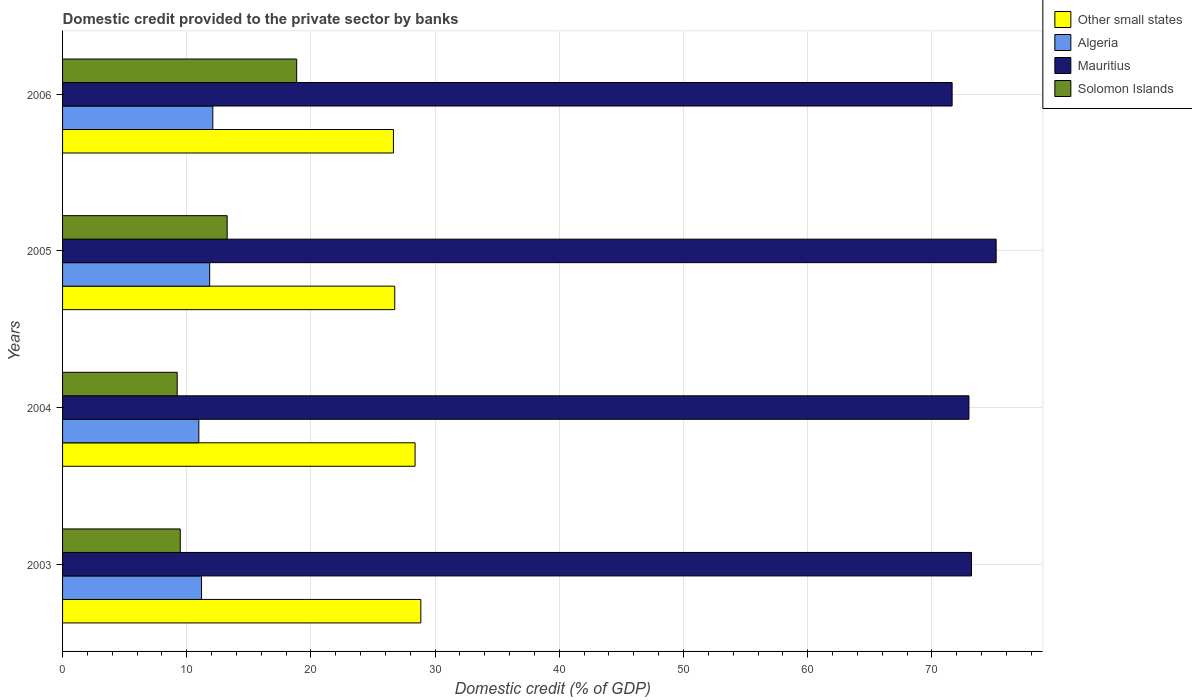How many different coloured bars are there?
Your response must be concise. 4. How many groups of bars are there?
Make the answer very short. 4. Are the number of bars on each tick of the Y-axis equal?
Make the answer very short. Yes. In how many cases, is the number of bars for a given year not equal to the number of legend labels?
Ensure brevity in your answer.  0. What is the domestic credit provided to the private sector by banks in Other small states in 2006?
Your answer should be very brief. 26.64. Across all years, what is the maximum domestic credit provided to the private sector by banks in Solomon Islands?
Your answer should be very brief. 18.85. Across all years, what is the minimum domestic credit provided to the private sector by banks in Other small states?
Provide a succinct answer. 26.64. In which year was the domestic credit provided to the private sector by banks in Other small states minimum?
Make the answer very short. 2006. What is the total domestic credit provided to the private sector by banks in Solomon Islands in the graph?
Make the answer very short. 50.81. What is the difference between the domestic credit provided to the private sector by banks in Solomon Islands in 2003 and that in 2006?
Make the answer very short. -9.37. What is the difference between the domestic credit provided to the private sector by banks in Algeria in 2004 and the domestic credit provided to the private sector by banks in Solomon Islands in 2003?
Give a very brief answer. 1.5. What is the average domestic credit provided to the private sector by banks in Mauritius per year?
Give a very brief answer. 73.25. In the year 2003, what is the difference between the domestic credit provided to the private sector by banks in Mauritius and domestic credit provided to the private sector by banks in Other small states?
Give a very brief answer. 44.34. In how many years, is the domestic credit provided to the private sector by banks in Solomon Islands greater than 72 %?
Your answer should be compact. 0. What is the ratio of the domestic credit provided to the private sector by banks in Algeria in 2003 to that in 2005?
Your answer should be very brief. 0.94. Is the difference between the domestic credit provided to the private sector by banks in Mauritius in 2003 and 2005 greater than the difference between the domestic credit provided to the private sector by banks in Other small states in 2003 and 2005?
Your answer should be compact. No. What is the difference between the highest and the second highest domestic credit provided to the private sector by banks in Mauritius?
Keep it short and to the point. 1.98. What is the difference between the highest and the lowest domestic credit provided to the private sector by banks in Mauritius?
Give a very brief answer. 3.55. In how many years, is the domestic credit provided to the private sector by banks in Algeria greater than the average domestic credit provided to the private sector by banks in Algeria taken over all years?
Offer a terse response. 2. Is it the case that in every year, the sum of the domestic credit provided to the private sector by banks in Algeria and domestic credit provided to the private sector by banks in Mauritius is greater than the sum of domestic credit provided to the private sector by banks in Other small states and domestic credit provided to the private sector by banks in Solomon Islands?
Keep it short and to the point. Yes. What does the 4th bar from the top in 2005 represents?
Your answer should be compact. Other small states. What does the 1st bar from the bottom in 2006 represents?
Offer a terse response. Other small states. How many bars are there?
Offer a terse response. 16. What is the difference between two consecutive major ticks on the X-axis?
Provide a short and direct response. 10. Are the values on the major ticks of X-axis written in scientific E-notation?
Provide a succinct answer. No. Does the graph contain any zero values?
Offer a terse response. No. Does the graph contain grids?
Give a very brief answer. Yes. How many legend labels are there?
Offer a terse response. 4. What is the title of the graph?
Ensure brevity in your answer.  Domestic credit provided to the private sector by banks. Does "United States" appear as one of the legend labels in the graph?
Your response must be concise. No. What is the label or title of the X-axis?
Provide a succinct answer. Domestic credit (% of GDP). What is the Domestic credit (% of GDP) of Other small states in 2003?
Offer a terse response. 28.85. What is the Domestic credit (% of GDP) of Algeria in 2003?
Your response must be concise. 11.19. What is the Domestic credit (% of GDP) in Mauritius in 2003?
Keep it short and to the point. 73.19. What is the Domestic credit (% of GDP) in Solomon Islands in 2003?
Your answer should be very brief. 9.48. What is the Domestic credit (% of GDP) in Other small states in 2004?
Keep it short and to the point. 28.39. What is the Domestic credit (% of GDP) of Algeria in 2004?
Your response must be concise. 10.97. What is the Domestic credit (% of GDP) in Mauritius in 2004?
Offer a very short reply. 72.99. What is the Domestic credit (% of GDP) of Solomon Islands in 2004?
Keep it short and to the point. 9.23. What is the Domestic credit (% of GDP) of Other small states in 2005?
Give a very brief answer. 26.75. What is the Domestic credit (% of GDP) in Algeria in 2005?
Provide a short and direct response. 11.85. What is the Domestic credit (% of GDP) of Mauritius in 2005?
Give a very brief answer. 75.18. What is the Domestic credit (% of GDP) of Solomon Islands in 2005?
Provide a short and direct response. 13.25. What is the Domestic credit (% of GDP) in Other small states in 2006?
Make the answer very short. 26.64. What is the Domestic credit (% of GDP) in Algeria in 2006?
Keep it short and to the point. 12.1. What is the Domestic credit (% of GDP) of Mauritius in 2006?
Your answer should be compact. 71.63. What is the Domestic credit (% of GDP) in Solomon Islands in 2006?
Keep it short and to the point. 18.85. Across all years, what is the maximum Domestic credit (% of GDP) of Other small states?
Offer a very short reply. 28.85. Across all years, what is the maximum Domestic credit (% of GDP) of Algeria?
Keep it short and to the point. 12.1. Across all years, what is the maximum Domestic credit (% of GDP) in Mauritius?
Ensure brevity in your answer.  75.18. Across all years, what is the maximum Domestic credit (% of GDP) in Solomon Islands?
Offer a very short reply. 18.85. Across all years, what is the minimum Domestic credit (% of GDP) in Other small states?
Your answer should be very brief. 26.64. Across all years, what is the minimum Domestic credit (% of GDP) in Algeria?
Keep it short and to the point. 10.97. Across all years, what is the minimum Domestic credit (% of GDP) in Mauritius?
Ensure brevity in your answer.  71.63. Across all years, what is the minimum Domestic credit (% of GDP) in Solomon Islands?
Offer a terse response. 9.23. What is the total Domestic credit (% of GDP) in Other small states in the graph?
Give a very brief answer. 110.63. What is the total Domestic credit (% of GDP) in Algeria in the graph?
Offer a terse response. 46.11. What is the total Domestic credit (% of GDP) of Mauritius in the graph?
Ensure brevity in your answer.  292.99. What is the total Domestic credit (% of GDP) in Solomon Islands in the graph?
Offer a very short reply. 50.81. What is the difference between the Domestic credit (% of GDP) of Other small states in 2003 and that in 2004?
Make the answer very short. 0.46. What is the difference between the Domestic credit (% of GDP) in Algeria in 2003 and that in 2004?
Offer a terse response. 0.22. What is the difference between the Domestic credit (% of GDP) of Mauritius in 2003 and that in 2004?
Make the answer very short. 0.21. What is the difference between the Domestic credit (% of GDP) of Solomon Islands in 2003 and that in 2004?
Provide a short and direct response. 0.25. What is the difference between the Domestic credit (% of GDP) of Other small states in 2003 and that in 2005?
Provide a short and direct response. 2.1. What is the difference between the Domestic credit (% of GDP) in Algeria in 2003 and that in 2005?
Your answer should be compact. -0.66. What is the difference between the Domestic credit (% of GDP) in Mauritius in 2003 and that in 2005?
Provide a succinct answer. -1.98. What is the difference between the Domestic credit (% of GDP) in Solomon Islands in 2003 and that in 2005?
Provide a succinct answer. -3.78. What is the difference between the Domestic credit (% of GDP) of Other small states in 2003 and that in 2006?
Offer a very short reply. 2.21. What is the difference between the Domestic credit (% of GDP) in Algeria in 2003 and that in 2006?
Your response must be concise. -0.91. What is the difference between the Domestic credit (% of GDP) of Mauritius in 2003 and that in 2006?
Provide a short and direct response. 1.56. What is the difference between the Domestic credit (% of GDP) of Solomon Islands in 2003 and that in 2006?
Your answer should be compact. -9.37. What is the difference between the Domestic credit (% of GDP) in Other small states in 2004 and that in 2005?
Your response must be concise. 1.64. What is the difference between the Domestic credit (% of GDP) of Algeria in 2004 and that in 2005?
Ensure brevity in your answer.  -0.87. What is the difference between the Domestic credit (% of GDP) of Mauritius in 2004 and that in 2005?
Provide a short and direct response. -2.19. What is the difference between the Domestic credit (% of GDP) in Solomon Islands in 2004 and that in 2005?
Give a very brief answer. -4.02. What is the difference between the Domestic credit (% of GDP) of Other small states in 2004 and that in 2006?
Make the answer very short. 1.74. What is the difference between the Domestic credit (% of GDP) in Algeria in 2004 and that in 2006?
Your answer should be compact. -1.12. What is the difference between the Domestic credit (% of GDP) in Mauritius in 2004 and that in 2006?
Give a very brief answer. 1.35. What is the difference between the Domestic credit (% of GDP) of Solomon Islands in 2004 and that in 2006?
Make the answer very short. -9.62. What is the difference between the Domestic credit (% of GDP) of Other small states in 2005 and that in 2006?
Provide a short and direct response. 0.11. What is the difference between the Domestic credit (% of GDP) in Algeria in 2005 and that in 2006?
Your answer should be compact. -0.25. What is the difference between the Domestic credit (% of GDP) of Mauritius in 2005 and that in 2006?
Your response must be concise. 3.55. What is the difference between the Domestic credit (% of GDP) of Solomon Islands in 2005 and that in 2006?
Make the answer very short. -5.6. What is the difference between the Domestic credit (% of GDP) in Other small states in 2003 and the Domestic credit (% of GDP) in Algeria in 2004?
Offer a very short reply. 17.88. What is the difference between the Domestic credit (% of GDP) in Other small states in 2003 and the Domestic credit (% of GDP) in Mauritius in 2004?
Make the answer very short. -44.14. What is the difference between the Domestic credit (% of GDP) of Other small states in 2003 and the Domestic credit (% of GDP) of Solomon Islands in 2004?
Provide a short and direct response. 19.62. What is the difference between the Domestic credit (% of GDP) of Algeria in 2003 and the Domestic credit (% of GDP) of Mauritius in 2004?
Give a very brief answer. -61.8. What is the difference between the Domestic credit (% of GDP) in Algeria in 2003 and the Domestic credit (% of GDP) in Solomon Islands in 2004?
Give a very brief answer. 1.96. What is the difference between the Domestic credit (% of GDP) in Mauritius in 2003 and the Domestic credit (% of GDP) in Solomon Islands in 2004?
Offer a terse response. 63.96. What is the difference between the Domestic credit (% of GDP) of Other small states in 2003 and the Domestic credit (% of GDP) of Algeria in 2005?
Ensure brevity in your answer.  17. What is the difference between the Domestic credit (% of GDP) of Other small states in 2003 and the Domestic credit (% of GDP) of Mauritius in 2005?
Give a very brief answer. -46.33. What is the difference between the Domestic credit (% of GDP) in Other small states in 2003 and the Domestic credit (% of GDP) in Solomon Islands in 2005?
Ensure brevity in your answer.  15.59. What is the difference between the Domestic credit (% of GDP) of Algeria in 2003 and the Domestic credit (% of GDP) of Mauritius in 2005?
Make the answer very short. -63.99. What is the difference between the Domestic credit (% of GDP) of Algeria in 2003 and the Domestic credit (% of GDP) of Solomon Islands in 2005?
Your answer should be compact. -2.06. What is the difference between the Domestic credit (% of GDP) of Mauritius in 2003 and the Domestic credit (% of GDP) of Solomon Islands in 2005?
Offer a very short reply. 59.94. What is the difference between the Domestic credit (% of GDP) of Other small states in 2003 and the Domestic credit (% of GDP) of Algeria in 2006?
Offer a very short reply. 16.75. What is the difference between the Domestic credit (% of GDP) in Other small states in 2003 and the Domestic credit (% of GDP) in Mauritius in 2006?
Provide a short and direct response. -42.78. What is the difference between the Domestic credit (% of GDP) of Other small states in 2003 and the Domestic credit (% of GDP) of Solomon Islands in 2006?
Give a very brief answer. 10. What is the difference between the Domestic credit (% of GDP) of Algeria in 2003 and the Domestic credit (% of GDP) of Mauritius in 2006?
Provide a succinct answer. -60.44. What is the difference between the Domestic credit (% of GDP) in Algeria in 2003 and the Domestic credit (% of GDP) in Solomon Islands in 2006?
Provide a short and direct response. -7.66. What is the difference between the Domestic credit (% of GDP) in Mauritius in 2003 and the Domestic credit (% of GDP) in Solomon Islands in 2006?
Your response must be concise. 54.34. What is the difference between the Domestic credit (% of GDP) of Other small states in 2004 and the Domestic credit (% of GDP) of Algeria in 2005?
Provide a succinct answer. 16.54. What is the difference between the Domestic credit (% of GDP) in Other small states in 2004 and the Domestic credit (% of GDP) in Mauritius in 2005?
Make the answer very short. -46.79. What is the difference between the Domestic credit (% of GDP) of Other small states in 2004 and the Domestic credit (% of GDP) of Solomon Islands in 2005?
Your answer should be very brief. 15.13. What is the difference between the Domestic credit (% of GDP) of Algeria in 2004 and the Domestic credit (% of GDP) of Mauritius in 2005?
Offer a very short reply. -64.2. What is the difference between the Domestic credit (% of GDP) in Algeria in 2004 and the Domestic credit (% of GDP) in Solomon Islands in 2005?
Your answer should be very brief. -2.28. What is the difference between the Domestic credit (% of GDP) of Mauritius in 2004 and the Domestic credit (% of GDP) of Solomon Islands in 2005?
Provide a short and direct response. 59.73. What is the difference between the Domestic credit (% of GDP) of Other small states in 2004 and the Domestic credit (% of GDP) of Algeria in 2006?
Provide a succinct answer. 16.29. What is the difference between the Domestic credit (% of GDP) in Other small states in 2004 and the Domestic credit (% of GDP) in Mauritius in 2006?
Ensure brevity in your answer.  -43.25. What is the difference between the Domestic credit (% of GDP) in Other small states in 2004 and the Domestic credit (% of GDP) in Solomon Islands in 2006?
Offer a terse response. 9.53. What is the difference between the Domestic credit (% of GDP) in Algeria in 2004 and the Domestic credit (% of GDP) in Mauritius in 2006?
Your answer should be very brief. -60.66. What is the difference between the Domestic credit (% of GDP) of Algeria in 2004 and the Domestic credit (% of GDP) of Solomon Islands in 2006?
Give a very brief answer. -7.88. What is the difference between the Domestic credit (% of GDP) in Mauritius in 2004 and the Domestic credit (% of GDP) in Solomon Islands in 2006?
Keep it short and to the point. 54.13. What is the difference between the Domestic credit (% of GDP) in Other small states in 2005 and the Domestic credit (% of GDP) in Algeria in 2006?
Make the answer very short. 14.65. What is the difference between the Domestic credit (% of GDP) of Other small states in 2005 and the Domestic credit (% of GDP) of Mauritius in 2006?
Give a very brief answer. -44.88. What is the difference between the Domestic credit (% of GDP) in Other small states in 2005 and the Domestic credit (% of GDP) in Solomon Islands in 2006?
Your answer should be compact. 7.9. What is the difference between the Domestic credit (% of GDP) of Algeria in 2005 and the Domestic credit (% of GDP) of Mauritius in 2006?
Ensure brevity in your answer.  -59.78. What is the difference between the Domestic credit (% of GDP) of Algeria in 2005 and the Domestic credit (% of GDP) of Solomon Islands in 2006?
Provide a short and direct response. -7. What is the difference between the Domestic credit (% of GDP) in Mauritius in 2005 and the Domestic credit (% of GDP) in Solomon Islands in 2006?
Keep it short and to the point. 56.33. What is the average Domestic credit (% of GDP) of Other small states per year?
Your answer should be very brief. 27.66. What is the average Domestic credit (% of GDP) in Algeria per year?
Your response must be concise. 11.53. What is the average Domestic credit (% of GDP) in Mauritius per year?
Give a very brief answer. 73.25. What is the average Domestic credit (% of GDP) in Solomon Islands per year?
Make the answer very short. 12.7. In the year 2003, what is the difference between the Domestic credit (% of GDP) in Other small states and Domestic credit (% of GDP) in Algeria?
Keep it short and to the point. 17.66. In the year 2003, what is the difference between the Domestic credit (% of GDP) of Other small states and Domestic credit (% of GDP) of Mauritius?
Your answer should be very brief. -44.34. In the year 2003, what is the difference between the Domestic credit (% of GDP) in Other small states and Domestic credit (% of GDP) in Solomon Islands?
Your answer should be very brief. 19.37. In the year 2003, what is the difference between the Domestic credit (% of GDP) of Algeria and Domestic credit (% of GDP) of Mauritius?
Your answer should be very brief. -62. In the year 2003, what is the difference between the Domestic credit (% of GDP) in Algeria and Domestic credit (% of GDP) in Solomon Islands?
Give a very brief answer. 1.71. In the year 2003, what is the difference between the Domestic credit (% of GDP) of Mauritius and Domestic credit (% of GDP) of Solomon Islands?
Your response must be concise. 63.72. In the year 2004, what is the difference between the Domestic credit (% of GDP) in Other small states and Domestic credit (% of GDP) in Algeria?
Give a very brief answer. 17.41. In the year 2004, what is the difference between the Domestic credit (% of GDP) in Other small states and Domestic credit (% of GDP) in Mauritius?
Your answer should be compact. -44.6. In the year 2004, what is the difference between the Domestic credit (% of GDP) in Other small states and Domestic credit (% of GDP) in Solomon Islands?
Your response must be concise. 19.15. In the year 2004, what is the difference between the Domestic credit (% of GDP) in Algeria and Domestic credit (% of GDP) in Mauritius?
Your answer should be very brief. -62.01. In the year 2004, what is the difference between the Domestic credit (% of GDP) in Algeria and Domestic credit (% of GDP) in Solomon Islands?
Your answer should be compact. 1.74. In the year 2004, what is the difference between the Domestic credit (% of GDP) of Mauritius and Domestic credit (% of GDP) of Solomon Islands?
Make the answer very short. 63.75. In the year 2005, what is the difference between the Domestic credit (% of GDP) of Other small states and Domestic credit (% of GDP) of Algeria?
Keep it short and to the point. 14.9. In the year 2005, what is the difference between the Domestic credit (% of GDP) in Other small states and Domestic credit (% of GDP) in Mauritius?
Make the answer very short. -48.43. In the year 2005, what is the difference between the Domestic credit (% of GDP) of Other small states and Domestic credit (% of GDP) of Solomon Islands?
Your answer should be compact. 13.49. In the year 2005, what is the difference between the Domestic credit (% of GDP) in Algeria and Domestic credit (% of GDP) in Mauritius?
Provide a short and direct response. -63.33. In the year 2005, what is the difference between the Domestic credit (% of GDP) of Algeria and Domestic credit (% of GDP) of Solomon Islands?
Make the answer very short. -1.41. In the year 2005, what is the difference between the Domestic credit (% of GDP) of Mauritius and Domestic credit (% of GDP) of Solomon Islands?
Offer a terse response. 61.92. In the year 2006, what is the difference between the Domestic credit (% of GDP) of Other small states and Domestic credit (% of GDP) of Algeria?
Your answer should be compact. 14.55. In the year 2006, what is the difference between the Domestic credit (% of GDP) in Other small states and Domestic credit (% of GDP) in Mauritius?
Give a very brief answer. -44.99. In the year 2006, what is the difference between the Domestic credit (% of GDP) in Other small states and Domestic credit (% of GDP) in Solomon Islands?
Your answer should be compact. 7.79. In the year 2006, what is the difference between the Domestic credit (% of GDP) of Algeria and Domestic credit (% of GDP) of Mauritius?
Your answer should be very brief. -59.53. In the year 2006, what is the difference between the Domestic credit (% of GDP) in Algeria and Domestic credit (% of GDP) in Solomon Islands?
Your answer should be compact. -6.75. In the year 2006, what is the difference between the Domestic credit (% of GDP) in Mauritius and Domestic credit (% of GDP) in Solomon Islands?
Keep it short and to the point. 52.78. What is the ratio of the Domestic credit (% of GDP) of Other small states in 2003 to that in 2004?
Make the answer very short. 1.02. What is the ratio of the Domestic credit (% of GDP) of Algeria in 2003 to that in 2004?
Make the answer very short. 1.02. What is the ratio of the Domestic credit (% of GDP) of Solomon Islands in 2003 to that in 2004?
Provide a short and direct response. 1.03. What is the ratio of the Domestic credit (% of GDP) in Other small states in 2003 to that in 2005?
Keep it short and to the point. 1.08. What is the ratio of the Domestic credit (% of GDP) in Algeria in 2003 to that in 2005?
Make the answer very short. 0.94. What is the ratio of the Domestic credit (% of GDP) of Mauritius in 2003 to that in 2005?
Your answer should be very brief. 0.97. What is the ratio of the Domestic credit (% of GDP) in Solomon Islands in 2003 to that in 2005?
Make the answer very short. 0.71. What is the ratio of the Domestic credit (% of GDP) in Other small states in 2003 to that in 2006?
Keep it short and to the point. 1.08. What is the ratio of the Domestic credit (% of GDP) in Algeria in 2003 to that in 2006?
Offer a very short reply. 0.93. What is the ratio of the Domestic credit (% of GDP) in Mauritius in 2003 to that in 2006?
Ensure brevity in your answer.  1.02. What is the ratio of the Domestic credit (% of GDP) in Solomon Islands in 2003 to that in 2006?
Offer a terse response. 0.5. What is the ratio of the Domestic credit (% of GDP) of Other small states in 2004 to that in 2005?
Provide a short and direct response. 1.06. What is the ratio of the Domestic credit (% of GDP) of Algeria in 2004 to that in 2005?
Give a very brief answer. 0.93. What is the ratio of the Domestic credit (% of GDP) in Mauritius in 2004 to that in 2005?
Your answer should be very brief. 0.97. What is the ratio of the Domestic credit (% of GDP) of Solomon Islands in 2004 to that in 2005?
Provide a succinct answer. 0.7. What is the ratio of the Domestic credit (% of GDP) of Other small states in 2004 to that in 2006?
Offer a terse response. 1.07. What is the ratio of the Domestic credit (% of GDP) in Algeria in 2004 to that in 2006?
Provide a succinct answer. 0.91. What is the ratio of the Domestic credit (% of GDP) of Mauritius in 2004 to that in 2006?
Your answer should be very brief. 1.02. What is the ratio of the Domestic credit (% of GDP) in Solomon Islands in 2004 to that in 2006?
Ensure brevity in your answer.  0.49. What is the ratio of the Domestic credit (% of GDP) of Algeria in 2005 to that in 2006?
Your answer should be very brief. 0.98. What is the ratio of the Domestic credit (% of GDP) of Mauritius in 2005 to that in 2006?
Make the answer very short. 1.05. What is the ratio of the Domestic credit (% of GDP) in Solomon Islands in 2005 to that in 2006?
Keep it short and to the point. 0.7. What is the difference between the highest and the second highest Domestic credit (% of GDP) in Other small states?
Ensure brevity in your answer.  0.46. What is the difference between the highest and the second highest Domestic credit (% of GDP) of Mauritius?
Keep it short and to the point. 1.98. What is the difference between the highest and the second highest Domestic credit (% of GDP) in Solomon Islands?
Make the answer very short. 5.6. What is the difference between the highest and the lowest Domestic credit (% of GDP) of Other small states?
Your answer should be compact. 2.21. What is the difference between the highest and the lowest Domestic credit (% of GDP) in Algeria?
Provide a succinct answer. 1.12. What is the difference between the highest and the lowest Domestic credit (% of GDP) in Mauritius?
Keep it short and to the point. 3.55. What is the difference between the highest and the lowest Domestic credit (% of GDP) in Solomon Islands?
Offer a very short reply. 9.62. 